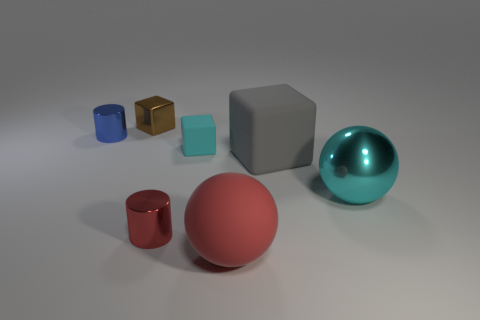Subtract 1 blocks. How many blocks are left? 2 Add 3 small gray cylinders. How many objects exist? 10 Subtract all cylinders. How many objects are left? 5 Subtract 0 blue balls. How many objects are left? 7 Subtract all tiny gray metal blocks. Subtract all big gray things. How many objects are left? 6 Add 7 small metallic things. How many small metallic things are left? 10 Add 7 tiny metallic things. How many tiny metallic things exist? 10 